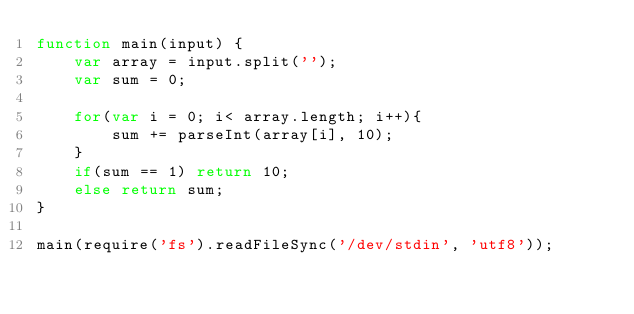Convert code to text. <code><loc_0><loc_0><loc_500><loc_500><_JavaScript_>function main(input) {
    var array = input.split('');
    var sum = 0;

    for(var i = 0; i< array.length; i++){
        sum += parseInt(array[i], 10);
    }
    if(sum == 1) return 10;
    else return sum;
}

main(require('fs').readFileSync('/dev/stdin', 'utf8'));</code> 